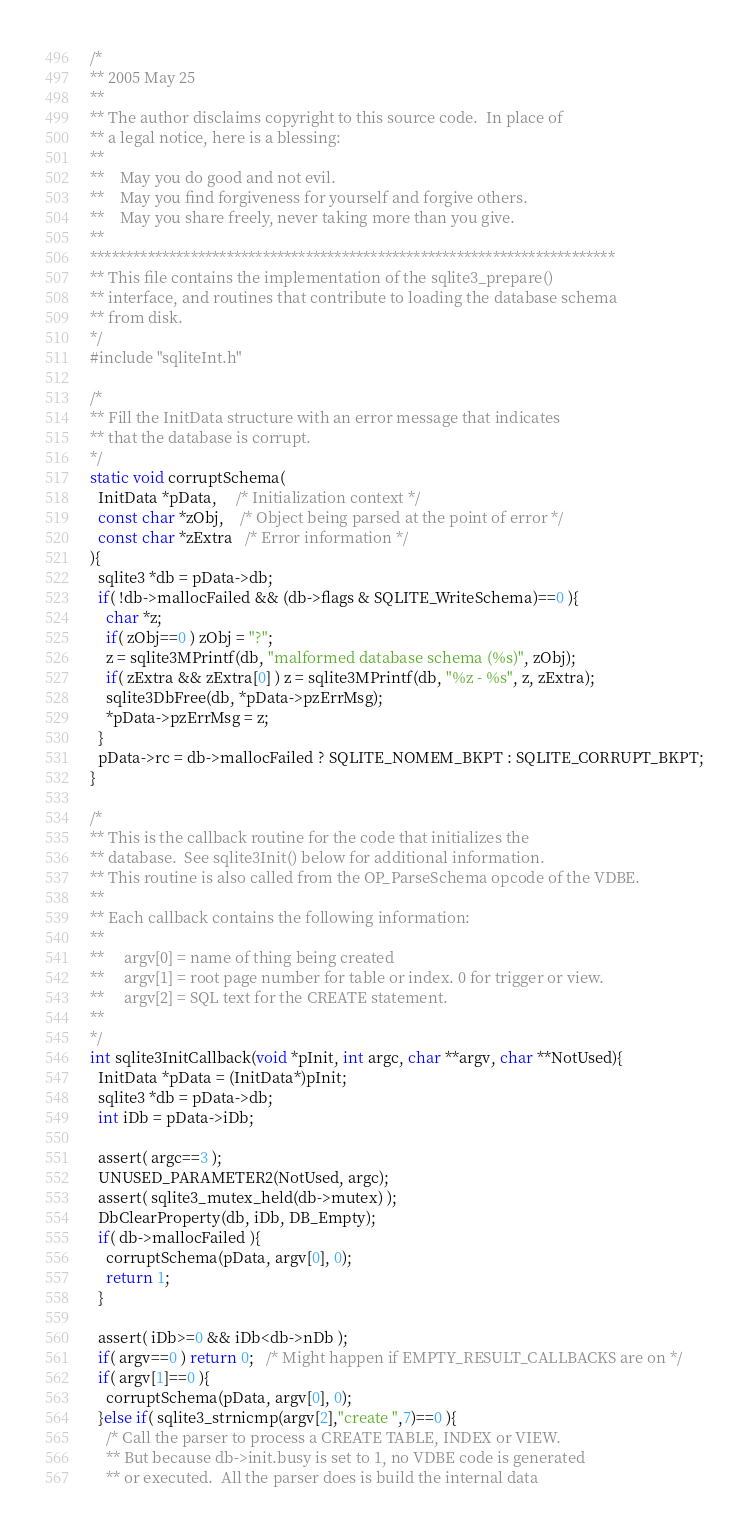Convert code to text. <code><loc_0><loc_0><loc_500><loc_500><_C_>/*
** 2005 May 25
**
** The author disclaims copyright to this source code.  In place of
** a legal notice, here is a blessing:
**
**    May you do good and not evil.
**    May you find forgiveness for yourself and forgive others.
**    May you share freely, never taking more than you give.
**
*************************************************************************
** This file contains the implementation of the sqlite3_prepare()
** interface, and routines that contribute to loading the database schema
** from disk.
*/
#include "sqliteInt.h"

/*
** Fill the InitData structure with an error message that indicates
** that the database is corrupt.
*/
static void corruptSchema(
  InitData *pData,     /* Initialization context */
  const char *zObj,    /* Object being parsed at the point of error */
  const char *zExtra   /* Error information */
){
  sqlite3 *db = pData->db;
  if( !db->mallocFailed && (db->flags & SQLITE_WriteSchema)==0 ){
    char *z;
    if( zObj==0 ) zObj = "?";
    z = sqlite3MPrintf(db, "malformed database schema (%s)", zObj);
    if( zExtra && zExtra[0] ) z = sqlite3MPrintf(db, "%z - %s", z, zExtra);
    sqlite3DbFree(db, *pData->pzErrMsg);
    *pData->pzErrMsg = z;
  }
  pData->rc = db->mallocFailed ? SQLITE_NOMEM_BKPT : SQLITE_CORRUPT_BKPT;
}

/*
** This is the callback routine for the code that initializes the
** database.  See sqlite3Init() below for additional information.
** This routine is also called from the OP_ParseSchema opcode of the VDBE.
**
** Each callback contains the following information:
**
**     argv[0] = name of thing being created
**     argv[1] = root page number for table or index. 0 for trigger or view.
**     argv[2] = SQL text for the CREATE statement.
**
*/
int sqlite3InitCallback(void *pInit, int argc, char **argv, char **NotUsed){
  InitData *pData = (InitData*)pInit;
  sqlite3 *db = pData->db;
  int iDb = pData->iDb;

  assert( argc==3 );
  UNUSED_PARAMETER2(NotUsed, argc);
  assert( sqlite3_mutex_held(db->mutex) );
  DbClearProperty(db, iDb, DB_Empty);
  if( db->mallocFailed ){
    corruptSchema(pData, argv[0], 0);
    return 1;
  }

  assert( iDb>=0 && iDb<db->nDb );
  if( argv==0 ) return 0;   /* Might happen if EMPTY_RESULT_CALLBACKS are on */
  if( argv[1]==0 ){
    corruptSchema(pData, argv[0], 0);
  }else if( sqlite3_strnicmp(argv[2],"create ",7)==0 ){
    /* Call the parser to process a CREATE TABLE, INDEX or VIEW.
    ** But because db->init.busy is set to 1, no VDBE code is generated
    ** or executed.  All the parser does is build the internal data</code> 